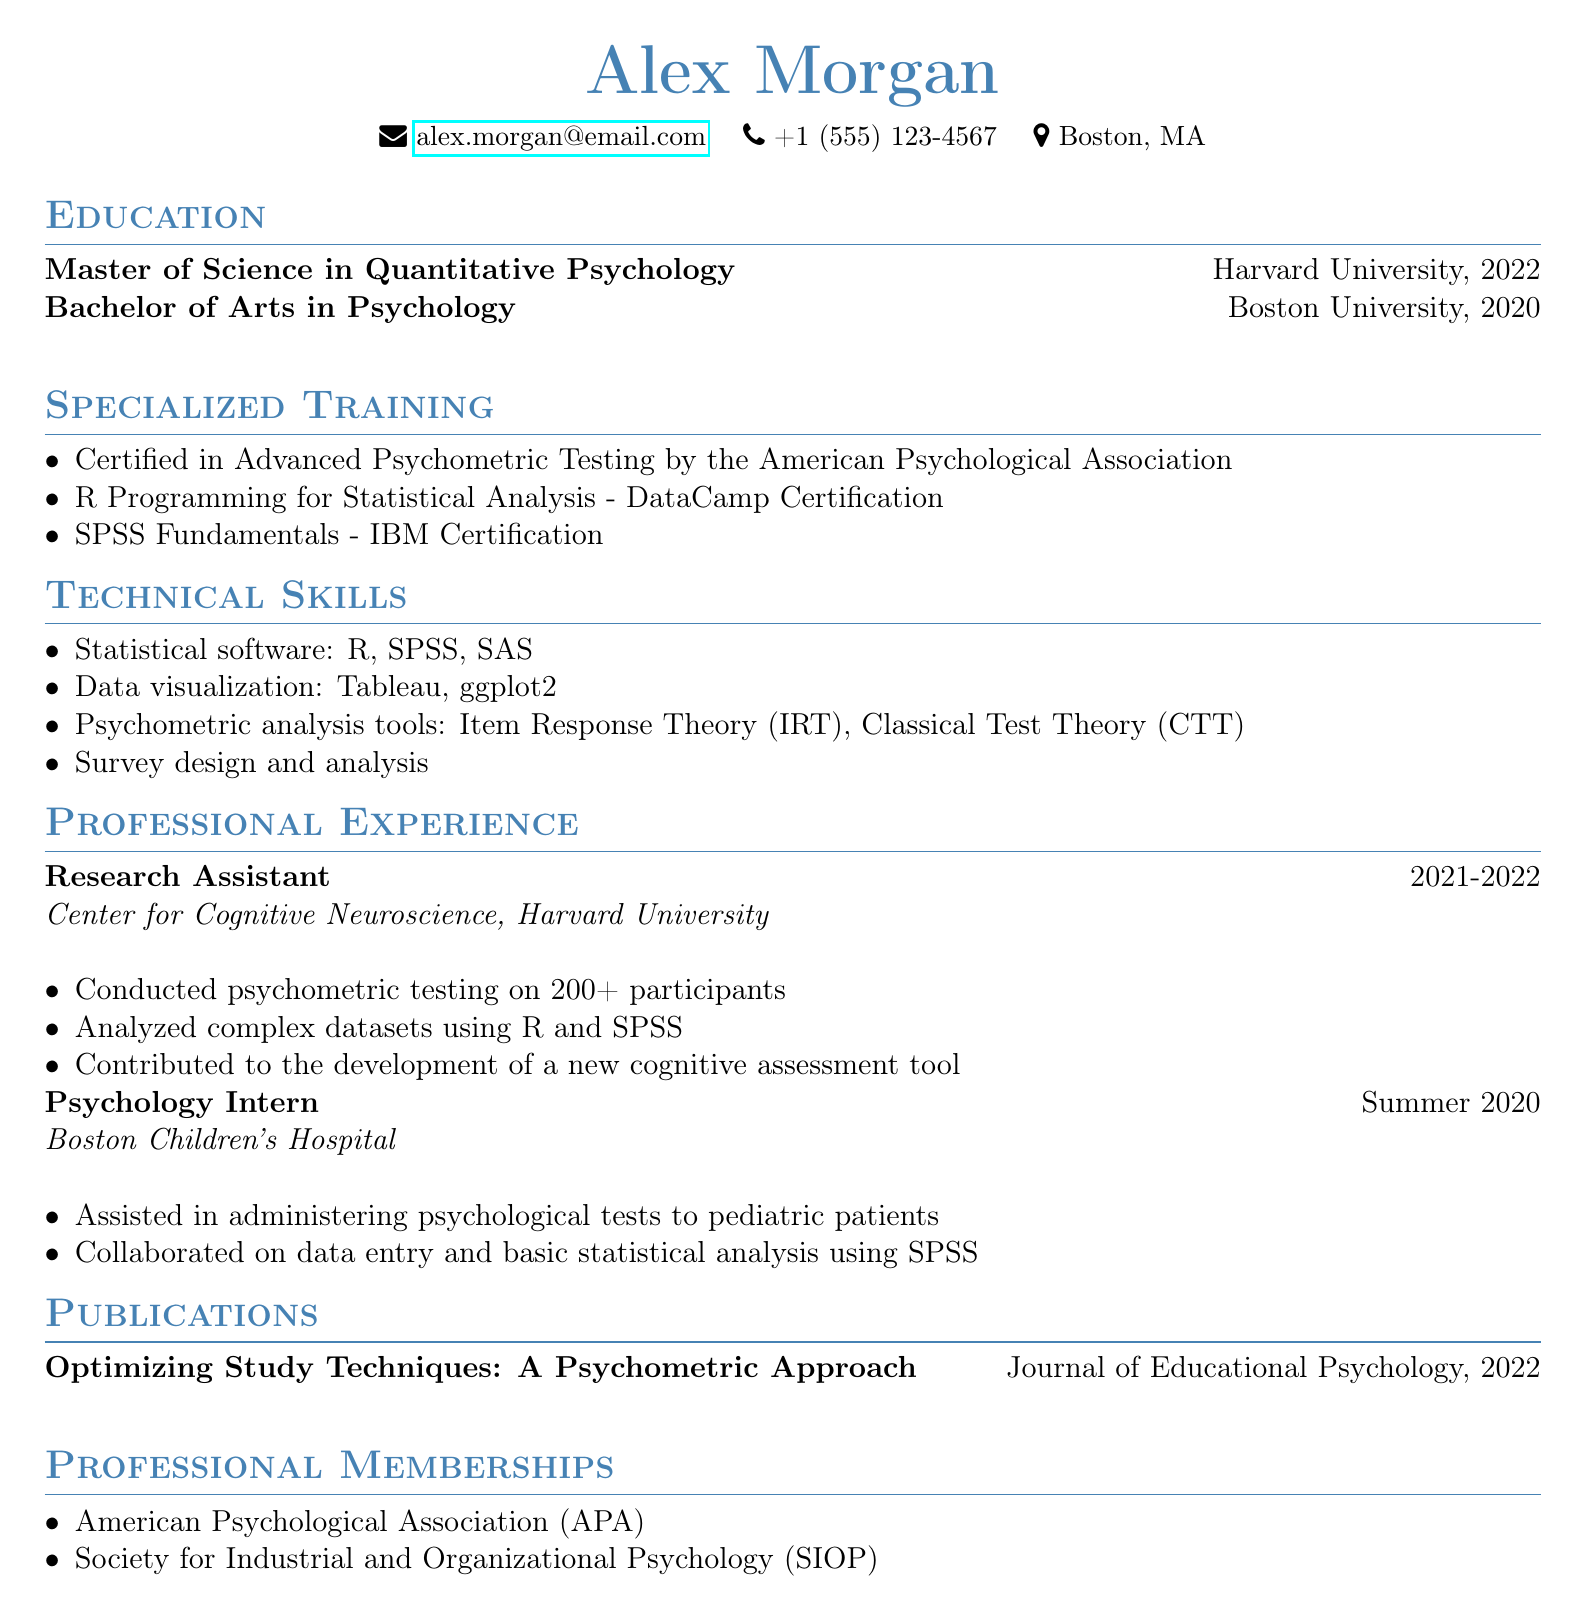what is the name of the individual? The document displays the name of the individual prominently at the top.
Answer: Alex Morgan which degree was obtained from Harvard University? The document lists degrees acquired by the individual with their respective institutions, focusing on the degree from Harvard.
Answer: Master of Science in Quantitative Psychology what certification is mentioned under specialized training? The document enumerates certifications relevant to the individual's qualifications and training in psychometric testing.
Answer: Certified in Advanced Psychometric Testing by the American Psychological Association how many participants were involved in the psychometric testing conducted by Alex Morgan? The document specifies the number of participants involved during the individual's role as a research assistant.
Answer: 200+ which statistical software is mentioned in the technical skills? The document lists technical skills, including statistical software that the individual is proficient in.
Answer: R, SPSS, SAS what was the position held at Boston Children's Hospital? The document outlines the individual's professional experience, including specific roles held in various organizations.
Answer: Psychology Intern in which publication did Alex Morgan's work appear? The document includes details about the individual's published work in a journal, indicating the title and where it was published.
Answer: Optimizing Study Techniques: A Psychometric Approach which professional membership is listed in the document? The document lists professional affiliations relevant to the individual's career in psychology.
Answer: American Psychological Association (APA) 